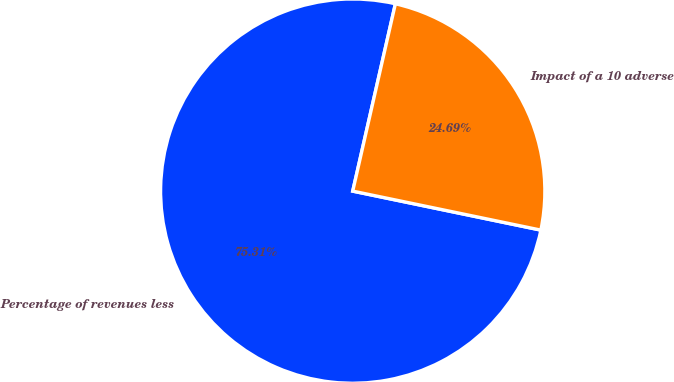Convert chart to OTSL. <chart><loc_0><loc_0><loc_500><loc_500><pie_chart><fcel>Percentage of revenues less<fcel>Impact of a 10 adverse<nl><fcel>75.31%<fcel>24.69%<nl></chart> 